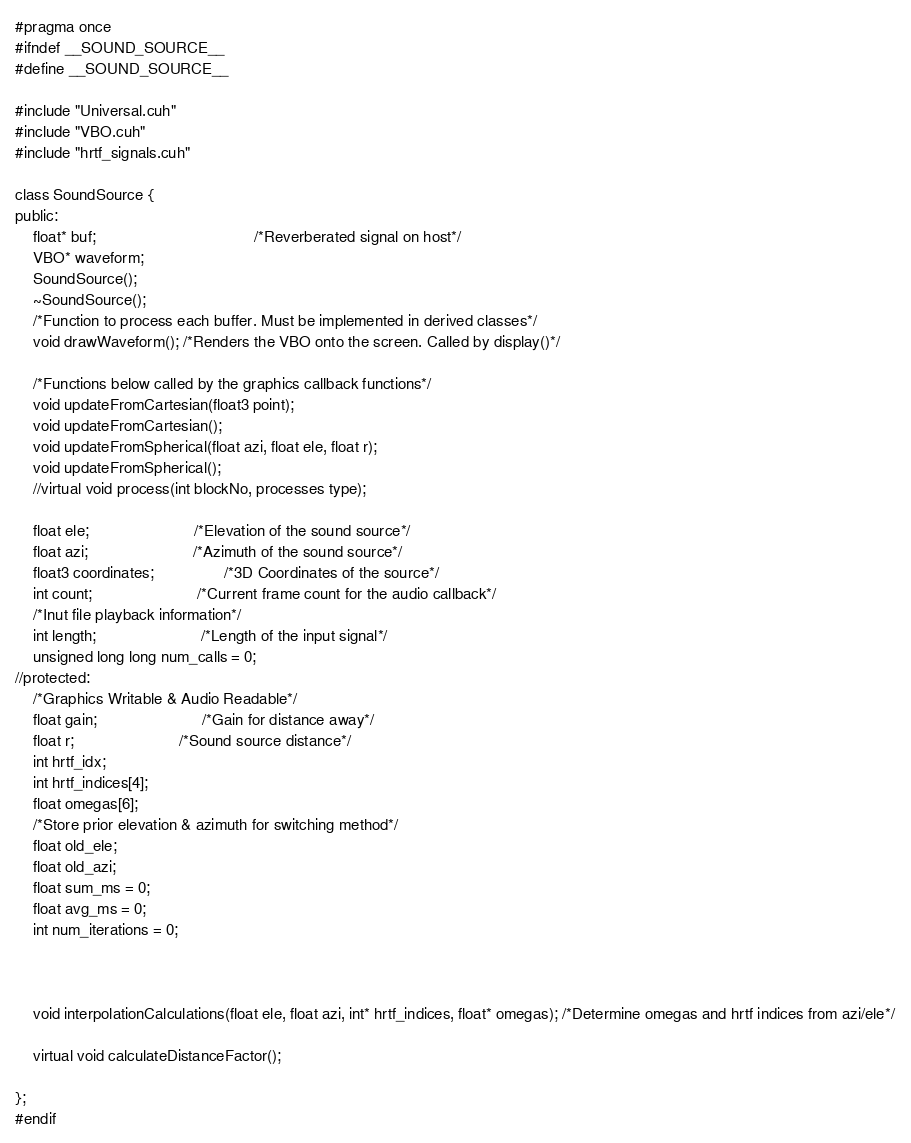Convert code to text. <code><loc_0><loc_0><loc_500><loc_500><_Cuda_>#pragma once
#ifndef __SOUND_SOURCE__
#define __SOUND_SOURCE__

#include "Universal.cuh"
#include "VBO.cuh"
#include "hrtf_signals.cuh"

class SoundSource {
public:
	float* buf;									/*Reverberated signal on host*/
	VBO* waveform;
	SoundSource();
	~SoundSource();
	/*Function to process each buffer. Must be implemented in derived classes*/
	void drawWaveform(); /*Renders the VBO onto the screen. Called by display()*/
	
	/*Functions below called by the graphics callback functions*/
	void updateFromCartesian(float3 point);
	void updateFromCartesian();
	void updateFromSpherical(float azi, float ele, float r);
	void updateFromSpherical();
	//virtual void process(int blockNo, processes type);

	float ele;						/*Elevation of the sound source*/
	float azi;						/*Azimuth of the sound source*/
	float3 coordinates;				/*3D Coordinates of the source*/
	int count;						/*Current frame count for the audio callback*/
	/*Inut file playback information*/
	int length;						/*Length of the input signal*/
	unsigned long long num_calls = 0;
//protected:
	/*Graphics Writable & Audio Readable*/
	float gain;						/*Gain for distance away*/
	float r;						/*Sound source distance*/
	int hrtf_idx;
	int hrtf_indices[4];
	float omegas[6];
	/*Store prior elevation & azimuth for switching method*/
	float old_ele;
	float old_azi;
	float sum_ms = 0;
	float avg_ms = 0;
	int num_iterations = 0;
	
	
	
	void interpolationCalculations(float ele, float azi, int* hrtf_indices, float* omegas); /*Determine omegas and hrtf indices from azi/ele*/
	
	virtual void calculateDistanceFactor();

};
#endif</code> 